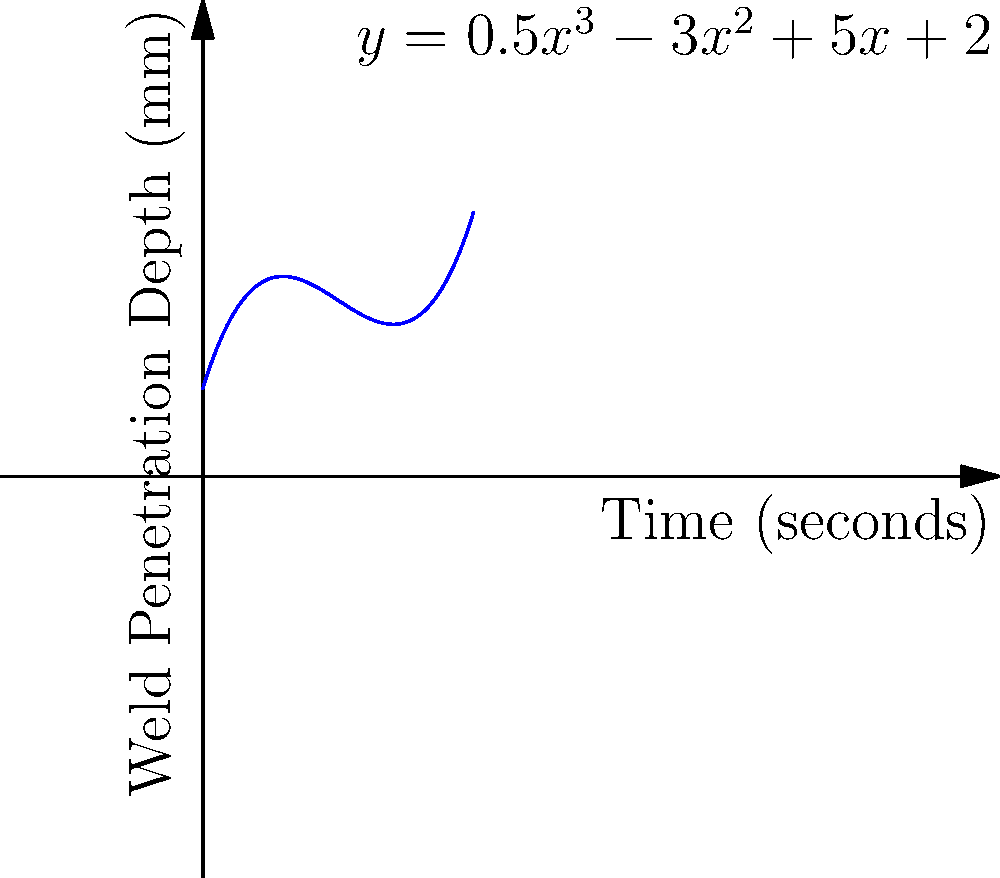The graph shows the relationship between welding time and weld penetration depth for a specific welding project. The equation of the curve is $y = 0.5x^3 - 3x^2 + 5x + 2$, where $y$ is the weld penetration depth in millimeters and $x$ is the welding time in seconds. At what time does the weld penetration depth reach its minimum value within the shown time range? To find the minimum point of the curve, we need to follow these steps:

1) The minimum point occurs where the derivative of the function equals zero. Let's find the derivative:

   $f'(x) = 1.5x^2 - 6x + 5$

2) Set the derivative equal to zero and solve for x:

   $1.5x^2 - 6x + 5 = 0$

3) This is a quadratic equation. We can solve it using the quadratic formula:
   $x = \frac{-b \pm \sqrt{b^2 - 4ac}}{2a}$

   Where $a = 1.5$, $b = -6$, and $c = 5$

4) Plugging in these values:

   $x = \frac{6 \pm \sqrt{36 - 30}}{3} = \frac{6 \pm \sqrt{6}}{3}$

5) This gives us two solutions:

   $x_1 = \frac{6 + \sqrt{6}}{3} \approx 2.82$ seconds
   $x_2 = \frac{6 - \sqrt{6}}{3} \approx 1.18$ seconds

6) Since we're asked for the minimum within the shown range (0 to 4 seconds), the answer is the smaller value, approximately 1.18 seconds.
Answer: 1.18 seconds 